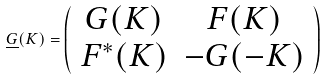<formula> <loc_0><loc_0><loc_500><loc_500>\underline { G } ( K ) = \left ( \begin{array} { c c } G ( K ) & F ( K ) \\ F ^ { * } ( K ) & - G ( - K ) \end{array} \right )</formula> 